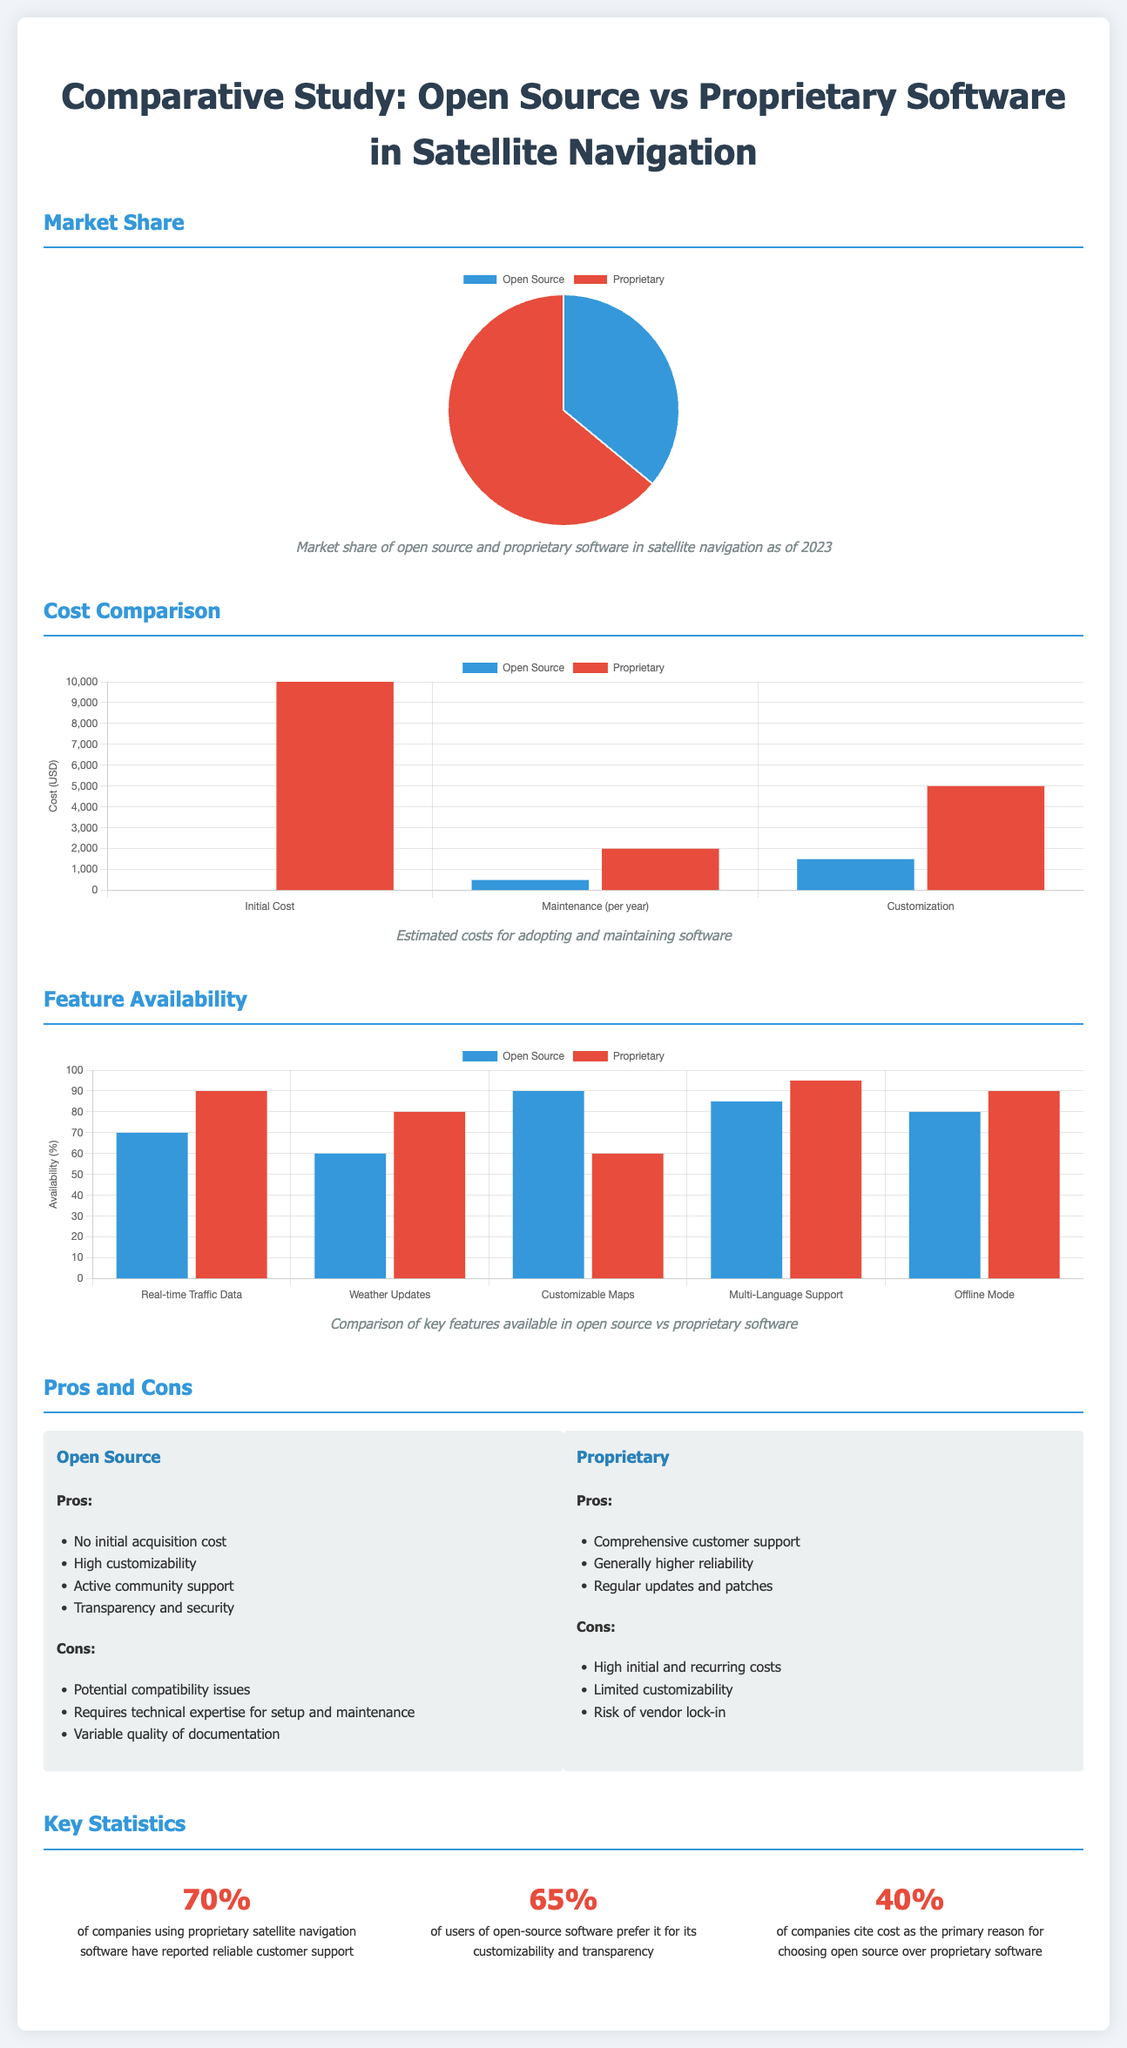what is the market share percentage of proprietary software? The document shows a pie chart indicating that proprietary software holds 64% of the market share in satellite navigation.
Answer: 64% what is the initial cost for adopting proprietary software? The bar chart specifies that the initial cost for proprietary software is $10,000.
Answer: $10,000 which key feature has the highest availability for open source software? The bar chart reveals that customizable maps have the highest availability at 90% for open source software.
Answer: 90% how many percent of companies using proprietary software reported reliable customer support? The key statistics section states that 70% of companies reported reliable customer support for proprietary software.
Answer: 70% what is the primary reason cited by companies for choosing open source software? The document mentions that 40% of companies cite cost as the primary reason for choosing open source software.
Answer: cost which software type has active community support? The pros list for open source software mentions that it has active community support.
Answer: open source which feature is preferred by users of open-source software for its customizability? The key statistics indicate that 65% of users prefer open-source software for its customizability and transparency.
Answer: customizability what is one disadvantage of using proprietary software? The cons list for proprietary software includes the risk of vendor lock-in, thus highlighting a disadvantage.
Answer: risk of vendor lock-in which type of software generally has higher reliability? The pros for proprietary software state that it generally has higher reliability.
Answer: proprietary 